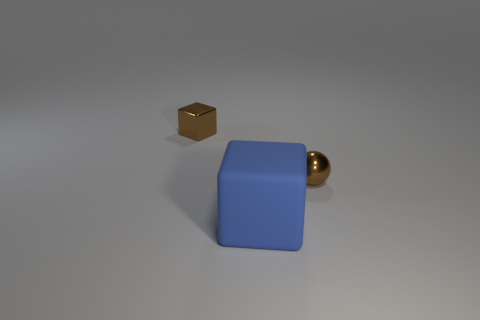Add 2 small brown spheres. How many objects exist? 5 Subtract all balls. How many objects are left? 2 Subtract 0 gray cubes. How many objects are left? 3 Subtract all tiny brown objects. Subtract all blue rubber blocks. How many objects are left? 0 Add 2 blue things. How many blue things are left? 3 Add 1 tiny spheres. How many tiny spheres exist? 2 